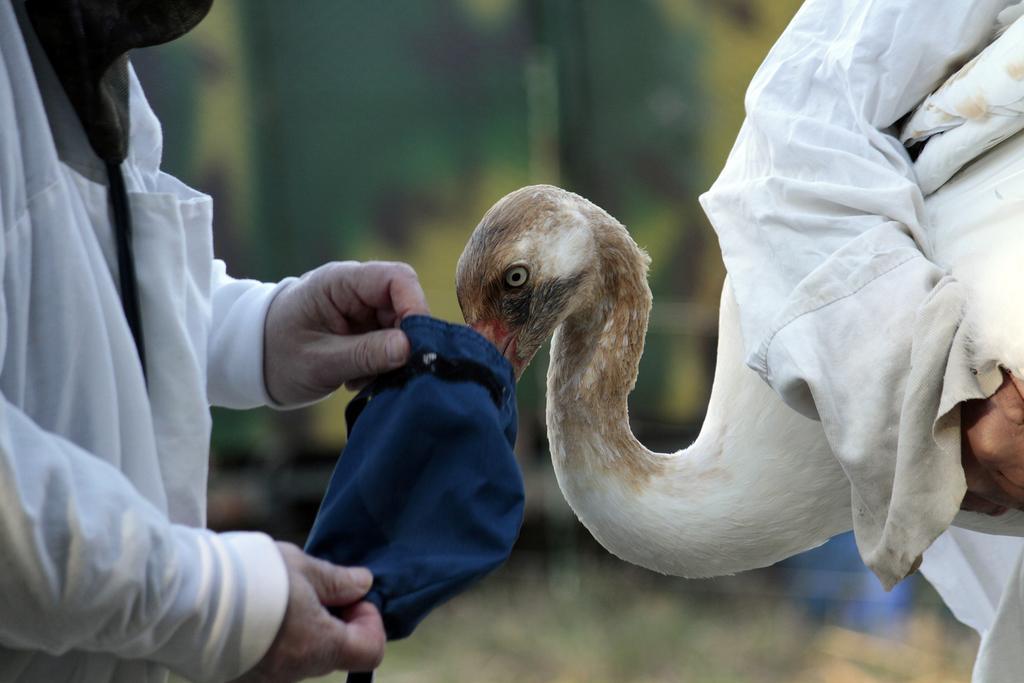Describe this image in one or two sentences. In this picture there is a man standing and holding a bag. On the right side of the image we can see a person holding a bird. In the background of the image it is blurry. 